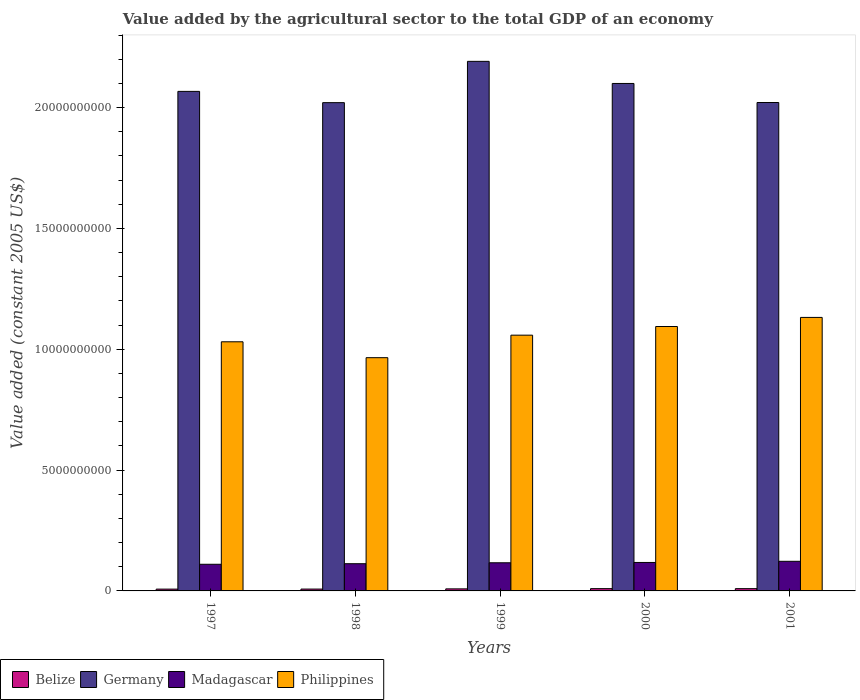How many different coloured bars are there?
Your answer should be compact. 4. Are the number of bars per tick equal to the number of legend labels?
Your answer should be very brief. Yes. Are the number of bars on each tick of the X-axis equal?
Offer a very short reply. Yes. What is the label of the 1st group of bars from the left?
Ensure brevity in your answer.  1997. What is the value added by the agricultural sector in Philippines in 1997?
Your answer should be very brief. 1.03e+1. Across all years, what is the maximum value added by the agricultural sector in Germany?
Keep it short and to the point. 2.19e+1. Across all years, what is the minimum value added by the agricultural sector in Belize?
Give a very brief answer. 7.47e+07. In which year was the value added by the agricultural sector in Germany maximum?
Your response must be concise. 1999. What is the total value added by the agricultural sector in Belize in the graph?
Ensure brevity in your answer.  4.24e+08. What is the difference between the value added by the agricultural sector in Belize in 2000 and that in 2001?
Your answer should be very brief. 3.72e+05. What is the difference between the value added by the agricultural sector in Philippines in 1997 and the value added by the agricultural sector in Madagascar in 1998?
Make the answer very short. 9.18e+09. What is the average value added by the agricultural sector in Madagascar per year?
Offer a terse response. 1.16e+09. In the year 1999, what is the difference between the value added by the agricultural sector in Philippines and value added by the agricultural sector in Belize?
Provide a short and direct response. 1.05e+1. What is the ratio of the value added by the agricultural sector in Germany in 1997 to that in 1999?
Your answer should be compact. 0.94. Is the value added by the agricultural sector in Madagascar in 1997 less than that in 1999?
Give a very brief answer. Yes. What is the difference between the highest and the second highest value added by the agricultural sector in Madagascar?
Keep it short and to the point. 4.74e+07. What is the difference between the highest and the lowest value added by the agricultural sector in Madagascar?
Give a very brief answer. 1.23e+08. What does the 4th bar from the right in 1999 represents?
Provide a succinct answer. Belize. Is it the case that in every year, the sum of the value added by the agricultural sector in Madagascar and value added by the agricultural sector in Germany is greater than the value added by the agricultural sector in Philippines?
Ensure brevity in your answer.  Yes. Are all the bars in the graph horizontal?
Offer a very short reply. No. How many years are there in the graph?
Ensure brevity in your answer.  5. What is the difference between two consecutive major ticks on the Y-axis?
Ensure brevity in your answer.  5.00e+09. Are the values on the major ticks of Y-axis written in scientific E-notation?
Ensure brevity in your answer.  No. Does the graph contain any zero values?
Your answer should be very brief. No. Where does the legend appear in the graph?
Provide a succinct answer. Bottom left. How many legend labels are there?
Ensure brevity in your answer.  4. What is the title of the graph?
Offer a terse response. Value added by the agricultural sector to the total GDP of an economy. What is the label or title of the X-axis?
Your answer should be compact. Years. What is the label or title of the Y-axis?
Provide a succinct answer. Value added (constant 2005 US$). What is the Value added (constant 2005 US$) in Belize in 1997?
Offer a terse response. 7.47e+07. What is the Value added (constant 2005 US$) in Germany in 1997?
Your answer should be compact. 2.07e+1. What is the Value added (constant 2005 US$) of Madagascar in 1997?
Provide a succinct answer. 1.10e+09. What is the Value added (constant 2005 US$) of Philippines in 1997?
Your response must be concise. 1.03e+1. What is the Value added (constant 2005 US$) in Belize in 1998?
Keep it short and to the point. 7.64e+07. What is the Value added (constant 2005 US$) in Germany in 1998?
Provide a short and direct response. 2.02e+1. What is the Value added (constant 2005 US$) in Madagascar in 1998?
Keep it short and to the point. 1.13e+09. What is the Value added (constant 2005 US$) of Philippines in 1998?
Offer a terse response. 9.65e+09. What is the Value added (constant 2005 US$) in Belize in 1999?
Your answer should be compact. 8.47e+07. What is the Value added (constant 2005 US$) in Germany in 1999?
Ensure brevity in your answer.  2.19e+1. What is the Value added (constant 2005 US$) in Madagascar in 1999?
Offer a terse response. 1.16e+09. What is the Value added (constant 2005 US$) in Philippines in 1999?
Make the answer very short. 1.06e+1. What is the Value added (constant 2005 US$) of Belize in 2000?
Ensure brevity in your answer.  9.45e+07. What is the Value added (constant 2005 US$) in Germany in 2000?
Offer a terse response. 2.10e+1. What is the Value added (constant 2005 US$) in Madagascar in 2000?
Give a very brief answer. 1.18e+09. What is the Value added (constant 2005 US$) in Philippines in 2000?
Make the answer very short. 1.09e+1. What is the Value added (constant 2005 US$) in Belize in 2001?
Keep it short and to the point. 9.41e+07. What is the Value added (constant 2005 US$) of Germany in 2001?
Your answer should be compact. 2.02e+1. What is the Value added (constant 2005 US$) of Madagascar in 2001?
Offer a terse response. 1.23e+09. What is the Value added (constant 2005 US$) of Philippines in 2001?
Provide a succinct answer. 1.13e+1. Across all years, what is the maximum Value added (constant 2005 US$) of Belize?
Offer a very short reply. 9.45e+07. Across all years, what is the maximum Value added (constant 2005 US$) of Germany?
Give a very brief answer. 2.19e+1. Across all years, what is the maximum Value added (constant 2005 US$) in Madagascar?
Offer a very short reply. 1.23e+09. Across all years, what is the maximum Value added (constant 2005 US$) in Philippines?
Your answer should be very brief. 1.13e+1. Across all years, what is the minimum Value added (constant 2005 US$) of Belize?
Offer a very short reply. 7.47e+07. Across all years, what is the minimum Value added (constant 2005 US$) of Germany?
Give a very brief answer. 2.02e+1. Across all years, what is the minimum Value added (constant 2005 US$) in Madagascar?
Provide a succinct answer. 1.10e+09. Across all years, what is the minimum Value added (constant 2005 US$) of Philippines?
Your answer should be very brief. 9.65e+09. What is the total Value added (constant 2005 US$) of Belize in the graph?
Provide a short and direct response. 4.24e+08. What is the total Value added (constant 2005 US$) in Germany in the graph?
Provide a succinct answer. 1.04e+11. What is the total Value added (constant 2005 US$) in Madagascar in the graph?
Offer a terse response. 5.80e+09. What is the total Value added (constant 2005 US$) of Philippines in the graph?
Provide a short and direct response. 5.28e+1. What is the difference between the Value added (constant 2005 US$) in Belize in 1997 and that in 1998?
Ensure brevity in your answer.  -1.71e+06. What is the difference between the Value added (constant 2005 US$) of Germany in 1997 and that in 1998?
Your answer should be compact. 4.66e+08. What is the difference between the Value added (constant 2005 US$) of Madagascar in 1997 and that in 1998?
Your answer should be compact. -2.36e+07. What is the difference between the Value added (constant 2005 US$) of Philippines in 1997 and that in 1998?
Your response must be concise. 6.58e+08. What is the difference between the Value added (constant 2005 US$) of Belize in 1997 and that in 1999?
Provide a succinct answer. -1.00e+07. What is the difference between the Value added (constant 2005 US$) in Germany in 1997 and that in 1999?
Make the answer very short. -1.24e+09. What is the difference between the Value added (constant 2005 US$) of Madagascar in 1997 and that in 1999?
Make the answer very short. -6.20e+07. What is the difference between the Value added (constant 2005 US$) in Philippines in 1997 and that in 1999?
Provide a succinct answer. -2.74e+08. What is the difference between the Value added (constant 2005 US$) in Belize in 1997 and that in 2000?
Your answer should be compact. -1.98e+07. What is the difference between the Value added (constant 2005 US$) in Germany in 1997 and that in 2000?
Ensure brevity in your answer.  -3.28e+08. What is the difference between the Value added (constant 2005 US$) in Madagascar in 1997 and that in 2000?
Offer a terse response. -7.51e+07. What is the difference between the Value added (constant 2005 US$) of Philippines in 1997 and that in 2000?
Make the answer very short. -6.32e+08. What is the difference between the Value added (constant 2005 US$) in Belize in 1997 and that in 2001?
Your response must be concise. -1.94e+07. What is the difference between the Value added (constant 2005 US$) of Germany in 1997 and that in 2001?
Provide a succinct answer. 4.60e+08. What is the difference between the Value added (constant 2005 US$) in Madagascar in 1997 and that in 2001?
Your answer should be compact. -1.23e+08. What is the difference between the Value added (constant 2005 US$) of Philippines in 1997 and that in 2001?
Ensure brevity in your answer.  -1.01e+09. What is the difference between the Value added (constant 2005 US$) of Belize in 1998 and that in 1999?
Offer a terse response. -8.30e+06. What is the difference between the Value added (constant 2005 US$) in Germany in 1998 and that in 1999?
Provide a short and direct response. -1.71e+09. What is the difference between the Value added (constant 2005 US$) in Madagascar in 1998 and that in 1999?
Give a very brief answer. -3.84e+07. What is the difference between the Value added (constant 2005 US$) of Philippines in 1998 and that in 1999?
Offer a very short reply. -9.31e+08. What is the difference between the Value added (constant 2005 US$) in Belize in 1998 and that in 2000?
Give a very brief answer. -1.81e+07. What is the difference between the Value added (constant 2005 US$) in Germany in 1998 and that in 2000?
Your answer should be compact. -7.94e+08. What is the difference between the Value added (constant 2005 US$) in Madagascar in 1998 and that in 2000?
Your answer should be compact. -5.16e+07. What is the difference between the Value added (constant 2005 US$) of Philippines in 1998 and that in 2000?
Make the answer very short. -1.29e+09. What is the difference between the Value added (constant 2005 US$) of Belize in 1998 and that in 2001?
Your response must be concise. -1.77e+07. What is the difference between the Value added (constant 2005 US$) in Germany in 1998 and that in 2001?
Keep it short and to the point. -6.11e+06. What is the difference between the Value added (constant 2005 US$) of Madagascar in 1998 and that in 2001?
Give a very brief answer. -9.89e+07. What is the difference between the Value added (constant 2005 US$) of Philippines in 1998 and that in 2001?
Ensure brevity in your answer.  -1.67e+09. What is the difference between the Value added (constant 2005 US$) in Belize in 1999 and that in 2000?
Your answer should be very brief. -9.77e+06. What is the difference between the Value added (constant 2005 US$) of Germany in 1999 and that in 2000?
Keep it short and to the point. 9.15e+08. What is the difference between the Value added (constant 2005 US$) in Madagascar in 1999 and that in 2000?
Ensure brevity in your answer.  -1.32e+07. What is the difference between the Value added (constant 2005 US$) of Philippines in 1999 and that in 2000?
Your answer should be compact. -3.58e+08. What is the difference between the Value added (constant 2005 US$) in Belize in 1999 and that in 2001?
Keep it short and to the point. -9.40e+06. What is the difference between the Value added (constant 2005 US$) of Germany in 1999 and that in 2001?
Provide a short and direct response. 1.70e+09. What is the difference between the Value added (constant 2005 US$) in Madagascar in 1999 and that in 2001?
Provide a short and direct response. -6.05e+07. What is the difference between the Value added (constant 2005 US$) in Philippines in 1999 and that in 2001?
Give a very brief answer. -7.35e+08. What is the difference between the Value added (constant 2005 US$) of Belize in 2000 and that in 2001?
Provide a succinct answer. 3.72e+05. What is the difference between the Value added (constant 2005 US$) in Germany in 2000 and that in 2001?
Make the answer very short. 7.88e+08. What is the difference between the Value added (constant 2005 US$) in Madagascar in 2000 and that in 2001?
Offer a terse response. -4.74e+07. What is the difference between the Value added (constant 2005 US$) in Philippines in 2000 and that in 2001?
Your response must be concise. -3.77e+08. What is the difference between the Value added (constant 2005 US$) of Belize in 1997 and the Value added (constant 2005 US$) of Germany in 1998?
Give a very brief answer. -2.01e+1. What is the difference between the Value added (constant 2005 US$) of Belize in 1997 and the Value added (constant 2005 US$) of Madagascar in 1998?
Give a very brief answer. -1.05e+09. What is the difference between the Value added (constant 2005 US$) in Belize in 1997 and the Value added (constant 2005 US$) in Philippines in 1998?
Offer a very short reply. -9.58e+09. What is the difference between the Value added (constant 2005 US$) in Germany in 1997 and the Value added (constant 2005 US$) in Madagascar in 1998?
Offer a terse response. 1.95e+1. What is the difference between the Value added (constant 2005 US$) of Germany in 1997 and the Value added (constant 2005 US$) of Philippines in 1998?
Your answer should be very brief. 1.10e+1. What is the difference between the Value added (constant 2005 US$) in Madagascar in 1997 and the Value added (constant 2005 US$) in Philippines in 1998?
Offer a terse response. -8.55e+09. What is the difference between the Value added (constant 2005 US$) in Belize in 1997 and the Value added (constant 2005 US$) in Germany in 1999?
Make the answer very short. -2.18e+1. What is the difference between the Value added (constant 2005 US$) of Belize in 1997 and the Value added (constant 2005 US$) of Madagascar in 1999?
Offer a terse response. -1.09e+09. What is the difference between the Value added (constant 2005 US$) in Belize in 1997 and the Value added (constant 2005 US$) in Philippines in 1999?
Make the answer very short. -1.05e+1. What is the difference between the Value added (constant 2005 US$) in Germany in 1997 and the Value added (constant 2005 US$) in Madagascar in 1999?
Provide a succinct answer. 1.95e+1. What is the difference between the Value added (constant 2005 US$) in Germany in 1997 and the Value added (constant 2005 US$) in Philippines in 1999?
Ensure brevity in your answer.  1.01e+1. What is the difference between the Value added (constant 2005 US$) of Madagascar in 1997 and the Value added (constant 2005 US$) of Philippines in 1999?
Provide a short and direct response. -9.48e+09. What is the difference between the Value added (constant 2005 US$) of Belize in 1997 and the Value added (constant 2005 US$) of Germany in 2000?
Your answer should be compact. -2.09e+1. What is the difference between the Value added (constant 2005 US$) in Belize in 1997 and the Value added (constant 2005 US$) in Madagascar in 2000?
Offer a terse response. -1.10e+09. What is the difference between the Value added (constant 2005 US$) of Belize in 1997 and the Value added (constant 2005 US$) of Philippines in 2000?
Your response must be concise. -1.09e+1. What is the difference between the Value added (constant 2005 US$) of Germany in 1997 and the Value added (constant 2005 US$) of Madagascar in 2000?
Your answer should be very brief. 1.95e+1. What is the difference between the Value added (constant 2005 US$) in Germany in 1997 and the Value added (constant 2005 US$) in Philippines in 2000?
Make the answer very short. 9.73e+09. What is the difference between the Value added (constant 2005 US$) in Madagascar in 1997 and the Value added (constant 2005 US$) in Philippines in 2000?
Give a very brief answer. -9.84e+09. What is the difference between the Value added (constant 2005 US$) of Belize in 1997 and the Value added (constant 2005 US$) of Germany in 2001?
Ensure brevity in your answer.  -2.01e+1. What is the difference between the Value added (constant 2005 US$) in Belize in 1997 and the Value added (constant 2005 US$) in Madagascar in 2001?
Your answer should be compact. -1.15e+09. What is the difference between the Value added (constant 2005 US$) in Belize in 1997 and the Value added (constant 2005 US$) in Philippines in 2001?
Ensure brevity in your answer.  -1.12e+1. What is the difference between the Value added (constant 2005 US$) in Germany in 1997 and the Value added (constant 2005 US$) in Madagascar in 2001?
Provide a short and direct response. 1.94e+1. What is the difference between the Value added (constant 2005 US$) in Germany in 1997 and the Value added (constant 2005 US$) in Philippines in 2001?
Keep it short and to the point. 9.35e+09. What is the difference between the Value added (constant 2005 US$) in Madagascar in 1997 and the Value added (constant 2005 US$) in Philippines in 2001?
Offer a terse response. -1.02e+1. What is the difference between the Value added (constant 2005 US$) of Belize in 1998 and the Value added (constant 2005 US$) of Germany in 1999?
Give a very brief answer. -2.18e+1. What is the difference between the Value added (constant 2005 US$) in Belize in 1998 and the Value added (constant 2005 US$) in Madagascar in 1999?
Keep it short and to the point. -1.09e+09. What is the difference between the Value added (constant 2005 US$) in Belize in 1998 and the Value added (constant 2005 US$) in Philippines in 1999?
Offer a terse response. -1.05e+1. What is the difference between the Value added (constant 2005 US$) in Germany in 1998 and the Value added (constant 2005 US$) in Madagascar in 1999?
Your answer should be very brief. 1.90e+1. What is the difference between the Value added (constant 2005 US$) in Germany in 1998 and the Value added (constant 2005 US$) in Philippines in 1999?
Offer a terse response. 9.62e+09. What is the difference between the Value added (constant 2005 US$) in Madagascar in 1998 and the Value added (constant 2005 US$) in Philippines in 1999?
Provide a succinct answer. -9.46e+09. What is the difference between the Value added (constant 2005 US$) of Belize in 1998 and the Value added (constant 2005 US$) of Germany in 2000?
Provide a succinct answer. -2.09e+1. What is the difference between the Value added (constant 2005 US$) of Belize in 1998 and the Value added (constant 2005 US$) of Madagascar in 2000?
Ensure brevity in your answer.  -1.10e+09. What is the difference between the Value added (constant 2005 US$) of Belize in 1998 and the Value added (constant 2005 US$) of Philippines in 2000?
Give a very brief answer. -1.09e+1. What is the difference between the Value added (constant 2005 US$) in Germany in 1998 and the Value added (constant 2005 US$) in Madagascar in 2000?
Ensure brevity in your answer.  1.90e+1. What is the difference between the Value added (constant 2005 US$) of Germany in 1998 and the Value added (constant 2005 US$) of Philippines in 2000?
Ensure brevity in your answer.  9.26e+09. What is the difference between the Value added (constant 2005 US$) in Madagascar in 1998 and the Value added (constant 2005 US$) in Philippines in 2000?
Offer a terse response. -9.81e+09. What is the difference between the Value added (constant 2005 US$) of Belize in 1998 and the Value added (constant 2005 US$) of Germany in 2001?
Ensure brevity in your answer.  -2.01e+1. What is the difference between the Value added (constant 2005 US$) of Belize in 1998 and the Value added (constant 2005 US$) of Madagascar in 2001?
Give a very brief answer. -1.15e+09. What is the difference between the Value added (constant 2005 US$) in Belize in 1998 and the Value added (constant 2005 US$) in Philippines in 2001?
Your response must be concise. -1.12e+1. What is the difference between the Value added (constant 2005 US$) of Germany in 1998 and the Value added (constant 2005 US$) of Madagascar in 2001?
Offer a very short reply. 1.90e+1. What is the difference between the Value added (constant 2005 US$) in Germany in 1998 and the Value added (constant 2005 US$) in Philippines in 2001?
Your answer should be very brief. 8.89e+09. What is the difference between the Value added (constant 2005 US$) in Madagascar in 1998 and the Value added (constant 2005 US$) in Philippines in 2001?
Offer a very short reply. -1.02e+1. What is the difference between the Value added (constant 2005 US$) of Belize in 1999 and the Value added (constant 2005 US$) of Germany in 2000?
Make the answer very short. -2.09e+1. What is the difference between the Value added (constant 2005 US$) in Belize in 1999 and the Value added (constant 2005 US$) in Madagascar in 2000?
Offer a terse response. -1.09e+09. What is the difference between the Value added (constant 2005 US$) of Belize in 1999 and the Value added (constant 2005 US$) of Philippines in 2000?
Keep it short and to the point. -1.09e+1. What is the difference between the Value added (constant 2005 US$) of Germany in 1999 and the Value added (constant 2005 US$) of Madagascar in 2000?
Provide a short and direct response. 2.07e+1. What is the difference between the Value added (constant 2005 US$) in Germany in 1999 and the Value added (constant 2005 US$) in Philippines in 2000?
Give a very brief answer. 1.10e+1. What is the difference between the Value added (constant 2005 US$) in Madagascar in 1999 and the Value added (constant 2005 US$) in Philippines in 2000?
Your answer should be compact. -9.78e+09. What is the difference between the Value added (constant 2005 US$) of Belize in 1999 and the Value added (constant 2005 US$) of Germany in 2001?
Provide a short and direct response. -2.01e+1. What is the difference between the Value added (constant 2005 US$) of Belize in 1999 and the Value added (constant 2005 US$) of Madagascar in 2001?
Make the answer very short. -1.14e+09. What is the difference between the Value added (constant 2005 US$) in Belize in 1999 and the Value added (constant 2005 US$) in Philippines in 2001?
Keep it short and to the point. -1.12e+1. What is the difference between the Value added (constant 2005 US$) in Germany in 1999 and the Value added (constant 2005 US$) in Madagascar in 2001?
Give a very brief answer. 2.07e+1. What is the difference between the Value added (constant 2005 US$) in Germany in 1999 and the Value added (constant 2005 US$) in Philippines in 2001?
Give a very brief answer. 1.06e+1. What is the difference between the Value added (constant 2005 US$) of Madagascar in 1999 and the Value added (constant 2005 US$) of Philippines in 2001?
Offer a very short reply. -1.02e+1. What is the difference between the Value added (constant 2005 US$) in Belize in 2000 and the Value added (constant 2005 US$) in Germany in 2001?
Offer a very short reply. -2.01e+1. What is the difference between the Value added (constant 2005 US$) of Belize in 2000 and the Value added (constant 2005 US$) of Madagascar in 2001?
Give a very brief answer. -1.13e+09. What is the difference between the Value added (constant 2005 US$) in Belize in 2000 and the Value added (constant 2005 US$) in Philippines in 2001?
Ensure brevity in your answer.  -1.12e+1. What is the difference between the Value added (constant 2005 US$) in Germany in 2000 and the Value added (constant 2005 US$) in Madagascar in 2001?
Offer a terse response. 1.98e+1. What is the difference between the Value added (constant 2005 US$) in Germany in 2000 and the Value added (constant 2005 US$) in Philippines in 2001?
Your response must be concise. 9.68e+09. What is the difference between the Value added (constant 2005 US$) of Madagascar in 2000 and the Value added (constant 2005 US$) of Philippines in 2001?
Offer a very short reply. -1.01e+1. What is the average Value added (constant 2005 US$) in Belize per year?
Offer a terse response. 8.49e+07. What is the average Value added (constant 2005 US$) of Germany per year?
Ensure brevity in your answer.  2.08e+1. What is the average Value added (constant 2005 US$) in Madagascar per year?
Ensure brevity in your answer.  1.16e+09. What is the average Value added (constant 2005 US$) of Philippines per year?
Provide a short and direct response. 1.06e+1. In the year 1997, what is the difference between the Value added (constant 2005 US$) of Belize and Value added (constant 2005 US$) of Germany?
Offer a terse response. -2.06e+1. In the year 1997, what is the difference between the Value added (constant 2005 US$) of Belize and Value added (constant 2005 US$) of Madagascar?
Make the answer very short. -1.03e+09. In the year 1997, what is the difference between the Value added (constant 2005 US$) of Belize and Value added (constant 2005 US$) of Philippines?
Give a very brief answer. -1.02e+1. In the year 1997, what is the difference between the Value added (constant 2005 US$) of Germany and Value added (constant 2005 US$) of Madagascar?
Offer a very short reply. 1.96e+1. In the year 1997, what is the difference between the Value added (constant 2005 US$) of Germany and Value added (constant 2005 US$) of Philippines?
Offer a terse response. 1.04e+1. In the year 1997, what is the difference between the Value added (constant 2005 US$) of Madagascar and Value added (constant 2005 US$) of Philippines?
Ensure brevity in your answer.  -9.21e+09. In the year 1998, what is the difference between the Value added (constant 2005 US$) in Belize and Value added (constant 2005 US$) in Germany?
Offer a very short reply. -2.01e+1. In the year 1998, what is the difference between the Value added (constant 2005 US$) in Belize and Value added (constant 2005 US$) in Madagascar?
Your answer should be very brief. -1.05e+09. In the year 1998, what is the difference between the Value added (constant 2005 US$) in Belize and Value added (constant 2005 US$) in Philippines?
Your response must be concise. -9.57e+09. In the year 1998, what is the difference between the Value added (constant 2005 US$) in Germany and Value added (constant 2005 US$) in Madagascar?
Ensure brevity in your answer.  1.91e+1. In the year 1998, what is the difference between the Value added (constant 2005 US$) in Germany and Value added (constant 2005 US$) in Philippines?
Provide a succinct answer. 1.06e+1. In the year 1998, what is the difference between the Value added (constant 2005 US$) of Madagascar and Value added (constant 2005 US$) of Philippines?
Your answer should be very brief. -8.52e+09. In the year 1999, what is the difference between the Value added (constant 2005 US$) of Belize and Value added (constant 2005 US$) of Germany?
Make the answer very short. -2.18e+1. In the year 1999, what is the difference between the Value added (constant 2005 US$) of Belize and Value added (constant 2005 US$) of Madagascar?
Provide a short and direct response. -1.08e+09. In the year 1999, what is the difference between the Value added (constant 2005 US$) of Belize and Value added (constant 2005 US$) of Philippines?
Ensure brevity in your answer.  -1.05e+1. In the year 1999, what is the difference between the Value added (constant 2005 US$) in Germany and Value added (constant 2005 US$) in Madagascar?
Your answer should be very brief. 2.07e+1. In the year 1999, what is the difference between the Value added (constant 2005 US$) in Germany and Value added (constant 2005 US$) in Philippines?
Offer a very short reply. 1.13e+1. In the year 1999, what is the difference between the Value added (constant 2005 US$) in Madagascar and Value added (constant 2005 US$) in Philippines?
Offer a terse response. -9.42e+09. In the year 2000, what is the difference between the Value added (constant 2005 US$) in Belize and Value added (constant 2005 US$) in Germany?
Keep it short and to the point. -2.09e+1. In the year 2000, what is the difference between the Value added (constant 2005 US$) of Belize and Value added (constant 2005 US$) of Madagascar?
Provide a short and direct response. -1.08e+09. In the year 2000, what is the difference between the Value added (constant 2005 US$) of Belize and Value added (constant 2005 US$) of Philippines?
Provide a short and direct response. -1.08e+1. In the year 2000, what is the difference between the Value added (constant 2005 US$) in Germany and Value added (constant 2005 US$) in Madagascar?
Your answer should be compact. 1.98e+1. In the year 2000, what is the difference between the Value added (constant 2005 US$) in Germany and Value added (constant 2005 US$) in Philippines?
Provide a short and direct response. 1.01e+1. In the year 2000, what is the difference between the Value added (constant 2005 US$) of Madagascar and Value added (constant 2005 US$) of Philippines?
Ensure brevity in your answer.  -9.76e+09. In the year 2001, what is the difference between the Value added (constant 2005 US$) in Belize and Value added (constant 2005 US$) in Germany?
Provide a succinct answer. -2.01e+1. In the year 2001, what is the difference between the Value added (constant 2005 US$) of Belize and Value added (constant 2005 US$) of Madagascar?
Offer a terse response. -1.13e+09. In the year 2001, what is the difference between the Value added (constant 2005 US$) of Belize and Value added (constant 2005 US$) of Philippines?
Make the answer very short. -1.12e+1. In the year 2001, what is the difference between the Value added (constant 2005 US$) in Germany and Value added (constant 2005 US$) in Madagascar?
Provide a succinct answer. 1.90e+1. In the year 2001, what is the difference between the Value added (constant 2005 US$) in Germany and Value added (constant 2005 US$) in Philippines?
Provide a short and direct response. 8.89e+09. In the year 2001, what is the difference between the Value added (constant 2005 US$) of Madagascar and Value added (constant 2005 US$) of Philippines?
Keep it short and to the point. -1.01e+1. What is the ratio of the Value added (constant 2005 US$) of Belize in 1997 to that in 1998?
Your answer should be compact. 0.98. What is the ratio of the Value added (constant 2005 US$) of Germany in 1997 to that in 1998?
Ensure brevity in your answer.  1.02. What is the ratio of the Value added (constant 2005 US$) in Madagascar in 1997 to that in 1998?
Your response must be concise. 0.98. What is the ratio of the Value added (constant 2005 US$) in Philippines in 1997 to that in 1998?
Offer a very short reply. 1.07. What is the ratio of the Value added (constant 2005 US$) of Belize in 1997 to that in 1999?
Provide a succinct answer. 0.88. What is the ratio of the Value added (constant 2005 US$) of Germany in 1997 to that in 1999?
Keep it short and to the point. 0.94. What is the ratio of the Value added (constant 2005 US$) of Madagascar in 1997 to that in 1999?
Your answer should be compact. 0.95. What is the ratio of the Value added (constant 2005 US$) in Philippines in 1997 to that in 1999?
Provide a succinct answer. 0.97. What is the ratio of the Value added (constant 2005 US$) in Belize in 1997 to that in 2000?
Your response must be concise. 0.79. What is the ratio of the Value added (constant 2005 US$) of Germany in 1997 to that in 2000?
Your response must be concise. 0.98. What is the ratio of the Value added (constant 2005 US$) of Madagascar in 1997 to that in 2000?
Your answer should be compact. 0.94. What is the ratio of the Value added (constant 2005 US$) of Philippines in 1997 to that in 2000?
Offer a terse response. 0.94. What is the ratio of the Value added (constant 2005 US$) of Belize in 1997 to that in 2001?
Give a very brief answer. 0.79. What is the ratio of the Value added (constant 2005 US$) of Germany in 1997 to that in 2001?
Keep it short and to the point. 1.02. What is the ratio of the Value added (constant 2005 US$) of Philippines in 1997 to that in 2001?
Offer a terse response. 0.91. What is the ratio of the Value added (constant 2005 US$) in Belize in 1998 to that in 1999?
Your answer should be compact. 0.9. What is the ratio of the Value added (constant 2005 US$) of Germany in 1998 to that in 1999?
Provide a short and direct response. 0.92. What is the ratio of the Value added (constant 2005 US$) of Madagascar in 1998 to that in 1999?
Keep it short and to the point. 0.97. What is the ratio of the Value added (constant 2005 US$) in Philippines in 1998 to that in 1999?
Provide a succinct answer. 0.91. What is the ratio of the Value added (constant 2005 US$) in Belize in 1998 to that in 2000?
Give a very brief answer. 0.81. What is the ratio of the Value added (constant 2005 US$) in Germany in 1998 to that in 2000?
Your answer should be compact. 0.96. What is the ratio of the Value added (constant 2005 US$) of Madagascar in 1998 to that in 2000?
Ensure brevity in your answer.  0.96. What is the ratio of the Value added (constant 2005 US$) of Philippines in 1998 to that in 2000?
Your answer should be very brief. 0.88. What is the ratio of the Value added (constant 2005 US$) in Belize in 1998 to that in 2001?
Ensure brevity in your answer.  0.81. What is the ratio of the Value added (constant 2005 US$) in Madagascar in 1998 to that in 2001?
Offer a very short reply. 0.92. What is the ratio of the Value added (constant 2005 US$) in Philippines in 1998 to that in 2001?
Your answer should be compact. 0.85. What is the ratio of the Value added (constant 2005 US$) of Belize in 1999 to that in 2000?
Ensure brevity in your answer.  0.9. What is the ratio of the Value added (constant 2005 US$) of Germany in 1999 to that in 2000?
Offer a terse response. 1.04. What is the ratio of the Value added (constant 2005 US$) of Madagascar in 1999 to that in 2000?
Make the answer very short. 0.99. What is the ratio of the Value added (constant 2005 US$) of Philippines in 1999 to that in 2000?
Ensure brevity in your answer.  0.97. What is the ratio of the Value added (constant 2005 US$) of Belize in 1999 to that in 2001?
Your answer should be very brief. 0.9. What is the ratio of the Value added (constant 2005 US$) of Germany in 1999 to that in 2001?
Provide a succinct answer. 1.08. What is the ratio of the Value added (constant 2005 US$) of Madagascar in 1999 to that in 2001?
Your response must be concise. 0.95. What is the ratio of the Value added (constant 2005 US$) in Philippines in 1999 to that in 2001?
Your response must be concise. 0.94. What is the ratio of the Value added (constant 2005 US$) of Belize in 2000 to that in 2001?
Your response must be concise. 1. What is the ratio of the Value added (constant 2005 US$) of Germany in 2000 to that in 2001?
Keep it short and to the point. 1.04. What is the ratio of the Value added (constant 2005 US$) of Madagascar in 2000 to that in 2001?
Your response must be concise. 0.96. What is the ratio of the Value added (constant 2005 US$) in Philippines in 2000 to that in 2001?
Offer a terse response. 0.97. What is the difference between the highest and the second highest Value added (constant 2005 US$) in Belize?
Your answer should be very brief. 3.72e+05. What is the difference between the highest and the second highest Value added (constant 2005 US$) of Germany?
Your answer should be compact. 9.15e+08. What is the difference between the highest and the second highest Value added (constant 2005 US$) in Madagascar?
Provide a short and direct response. 4.74e+07. What is the difference between the highest and the second highest Value added (constant 2005 US$) in Philippines?
Provide a short and direct response. 3.77e+08. What is the difference between the highest and the lowest Value added (constant 2005 US$) of Belize?
Provide a short and direct response. 1.98e+07. What is the difference between the highest and the lowest Value added (constant 2005 US$) of Germany?
Your answer should be very brief. 1.71e+09. What is the difference between the highest and the lowest Value added (constant 2005 US$) of Madagascar?
Your answer should be very brief. 1.23e+08. What is the difference between the highest and the lowest Value added (constant 2005 US$) in Philippines?
Your answer should be very brief. 1.67e+09. 